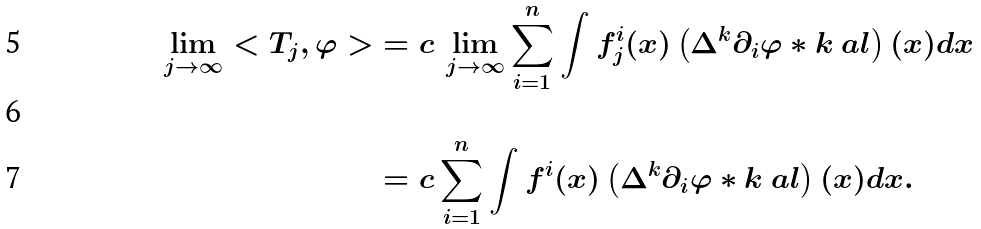<formula> <loc_0><loc_0><loc_500><loc_500>\lim _ { j \to \infty } < T _ { j } , \varphi > & = c \, \lim _ { j \to \infty } \sum _ { i = 1 } ^ { n } \int f _ { j } ^ { i } ( x ) \left ( \Delta ^ { k } \partial _ { i } \varphi * k _ { \ } a l \right ) ( x ) d x \\ \\ & = c \sum _ { i = 1 } ^ { n } \int f ^ { i } ( x ) \left ( \Delta ^ { k } \partial _ { i } \varphi * k _ { \ } a l \right ) ( x ) d x .</formula> 